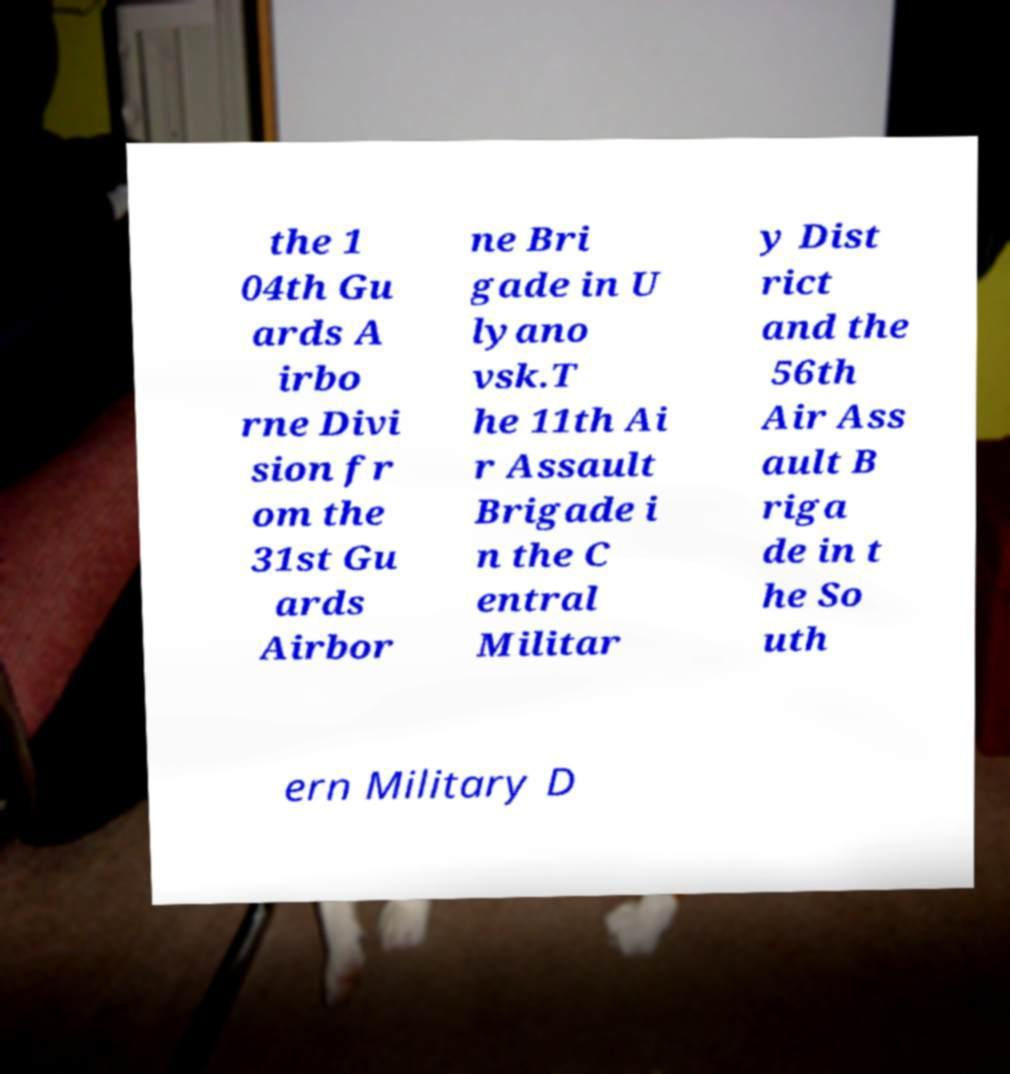There's text embedded in this image that I need extracted. Can you transcribe it verbatim? the 1 04th Gu ards A irbo rne Divi sion fr om the 31st Gu ards Airbor ne Bri gade in U lyano vsk.T he 11th Ai r Assault Brigade i n the C entral Militar y Dist rict and the 56th Air Ass ault B riga de in t he So uth ern Military D 